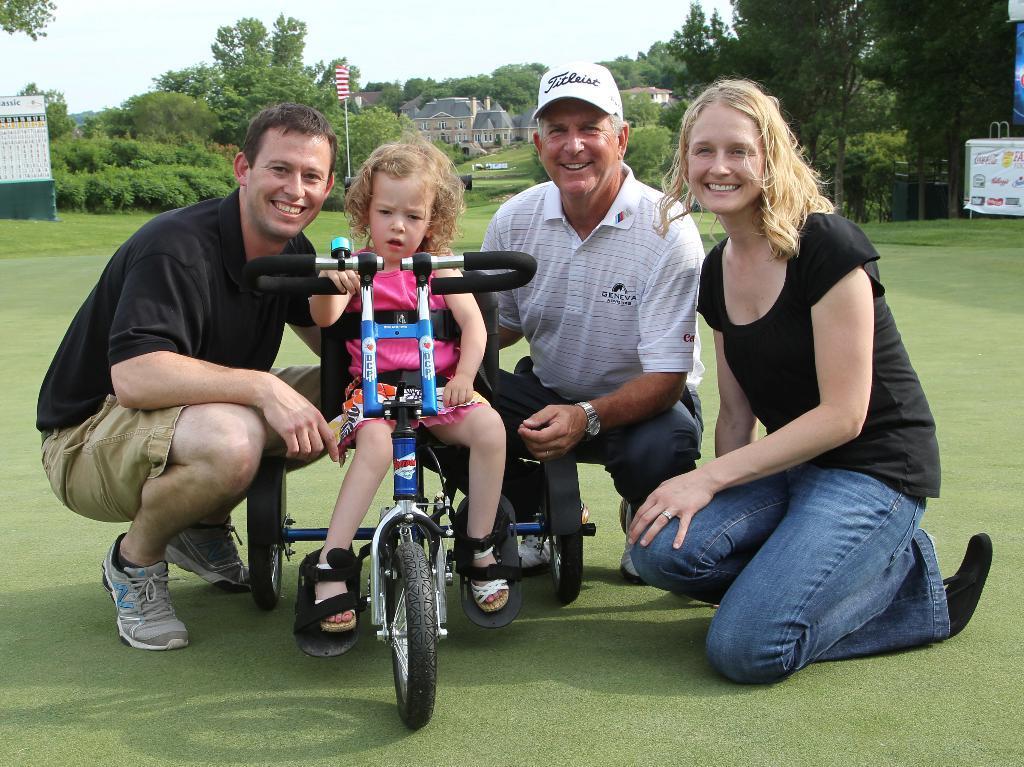How would you summarize this image in a sentence or two? On the left side, there is a person in black color T-shirt, smiling and squinting. Beside him, there is a baby sitting on a wheel chair. Beside this wheelchair, there are two persons smiling on the grass on the ground. In the background, there are trees, buildings, hoardings and there is blue sky. 